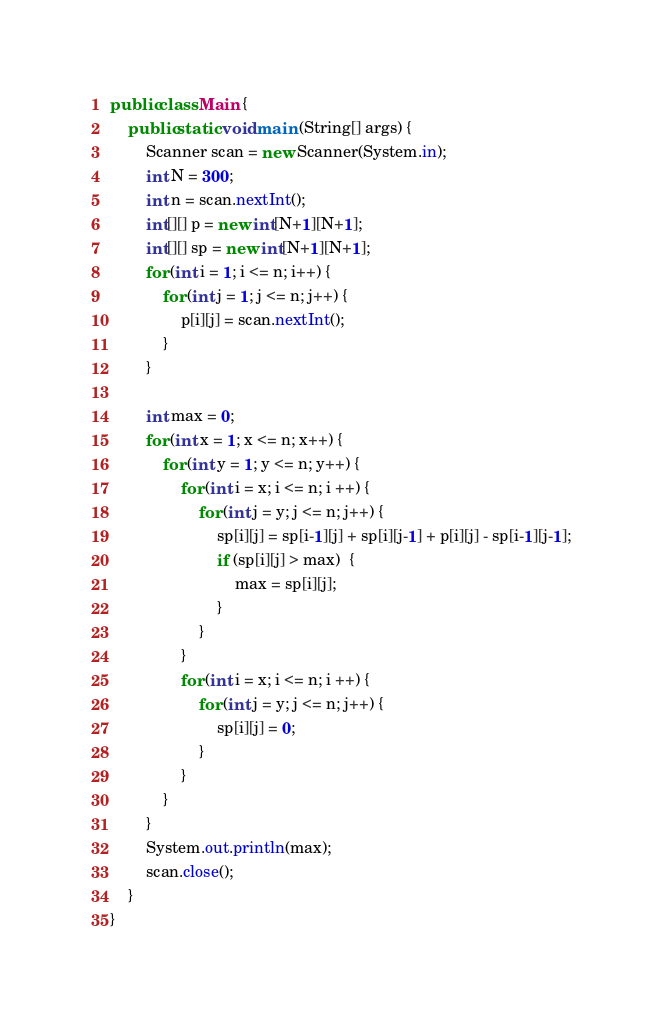<code> <loc_0><loc_0><loc_500><loc_500><_Java_>public class Main {
	public static void main (String[] args) {
		Scanner scan = new Scanner(System.in);
		int N = 300;
		int n = scan.nextInt();
		int[][] p = new int[N+1][N+1];
		int[][] sp = new int[N+1][N+1];
		for (int i = 1; i <= n; i++) {
			for (int j = 1; j <= n; j++) {
				p[i][j] = scan.nextInt();
			}
		}
		
		int max = 0;
		for (int x = 1; x <= n; x++) {
			for (int y = 1; y <= n; y++) {
				for (int i = x; i <= n; i ++) {
					for (int j = y; j <= n; j++) {
						sp[i][j] = sp[i-1][j] + sp[i][j-1] + p[i][j] - sp[i-1][j-1];
						if (sp[i][j] > max)  {
							max = sp[i][j];
						}
					}
				}
				for (int i = x; i <= n; i ++) {
					for (int j = y; j <= n; j++) {
						sp[i][j] = 0;
					}
				}
			}
		}
		System.out.println(max);
		scan.close();
	}
}</code> 